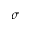Convert formula to latex. <formula><loc_0><loc_0><loc_500><loc_500>\sigma</formula> 